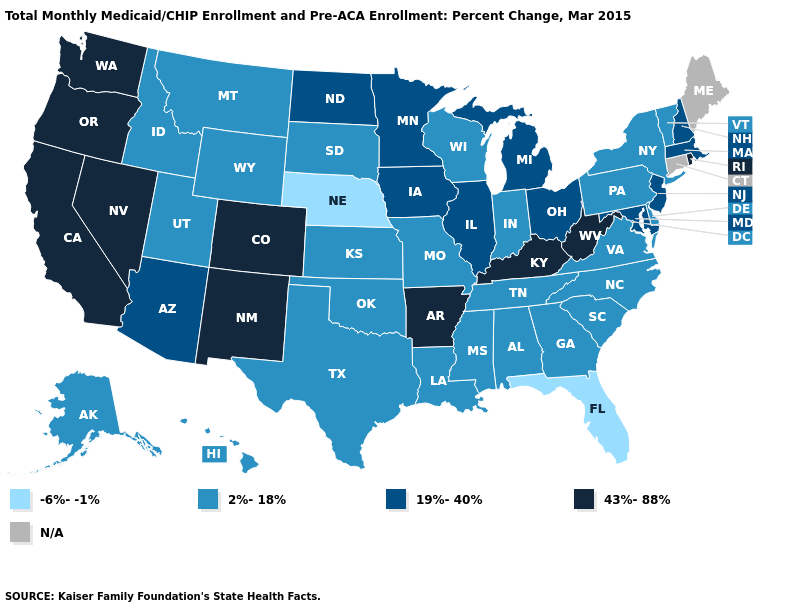Among the states that border Oregon , which have the highest value?
Answer briefly. California, Nevada, Washington. Among the states that border North Dakota , does Minnesota have the lowest value?
Quick response, please. No. Among the states that border Wyoming , which have the lowest value?
Keep it brief. Nebraska. What is the value of Vermont?
Be succinct. 2%-18%. What is the value of Alaska?
Concise answer only. 2%-18%. How many symbols are there in the legend?
Answer briefly. 5. Among the states that border Alabama , does Tennessee have the highest value?
Give a very brief answer. Yes. Among the states that border Virginia , does Maryland have the lowest value?
Be succinct. No. Does Vermont have the lowest value in the Northeast?
Keep it brief. Yes. Does Florida have the lowest value in the USA?
Give a very brief answer. Yes. What is the highest value in the USA?
Keep it brief. 43%-88%. Which states hav the highest value in the MidWest?
Concise answer only. Illinois, Iowa, Michigan, Minnesota, North Dakota, Ohio. Does Iowa have the highest value in the MidWest?
Be succinct. Yes. Among the states that border Oklahoma , which have the lowest value?
Quick response, please. Kansas, Missouri, Texas. What is the lowest value in states that border Nevada?
Answer briefly. 2%-18%. 